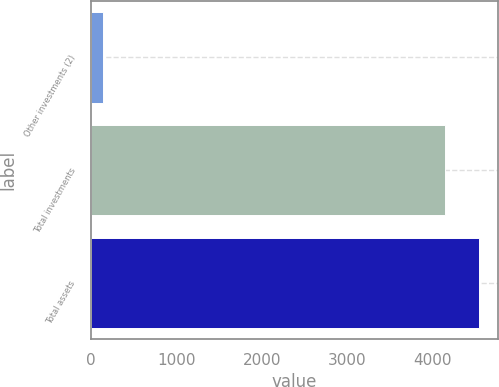<chart> <loc_0><loc_0><loc_500><loc_500><bar_chart><fcel>Other investments (2)<fcel>Total investments<fcel>Total assets<nl><fcel>148<fcel>4140<fcel>4539.2<nl></chart> 